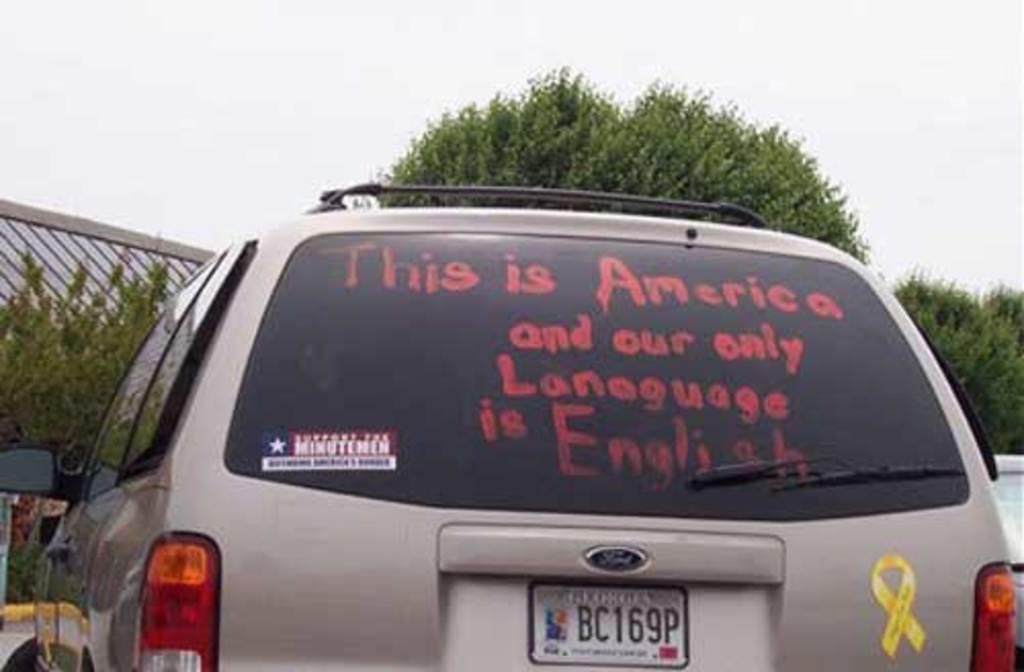What only language does this person think america speaks?
Provide a succinct answer. English. What is the license plate number of the van?
Ensure brevity in your answer.  Bc169p. 